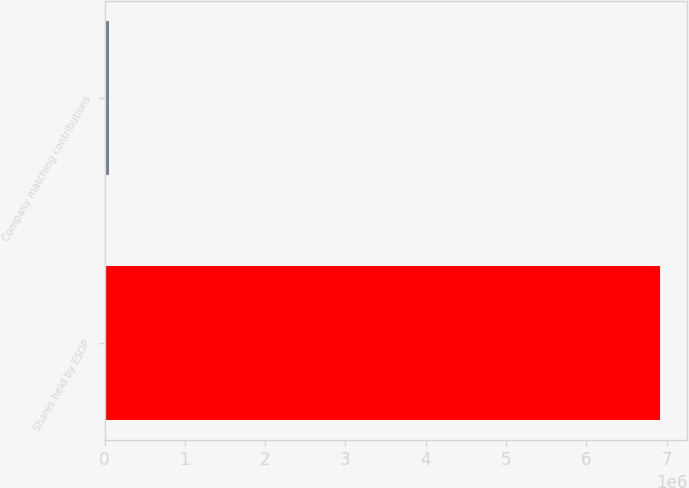Convert chart to OTSL. <chart><loc_0><loc_0><loc_500><loc_500><bar_chart><fcel>Shares held by ESOP<fcel>Company matching contributions<nl><fcel>6.91144e+06<fcel>57766<nl></chart> 